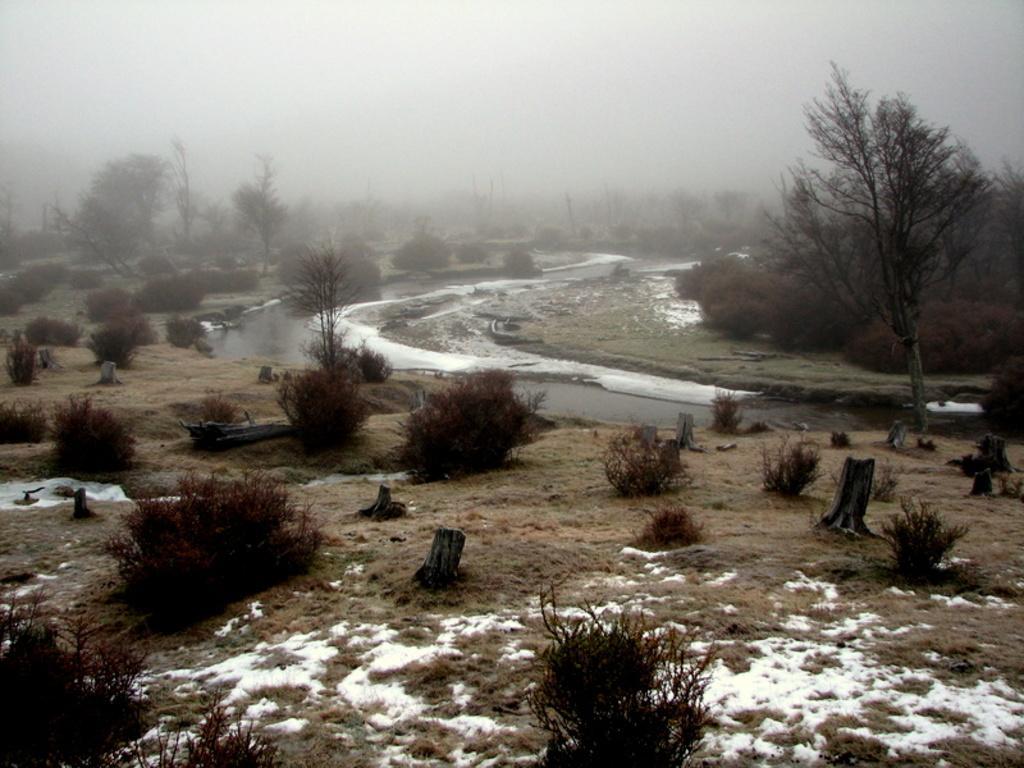Can you describe this image briefly? In the foreground of this picture, there are plants, snow and the ground. In the background, there is a river, trees, and the sky covered with fog. 